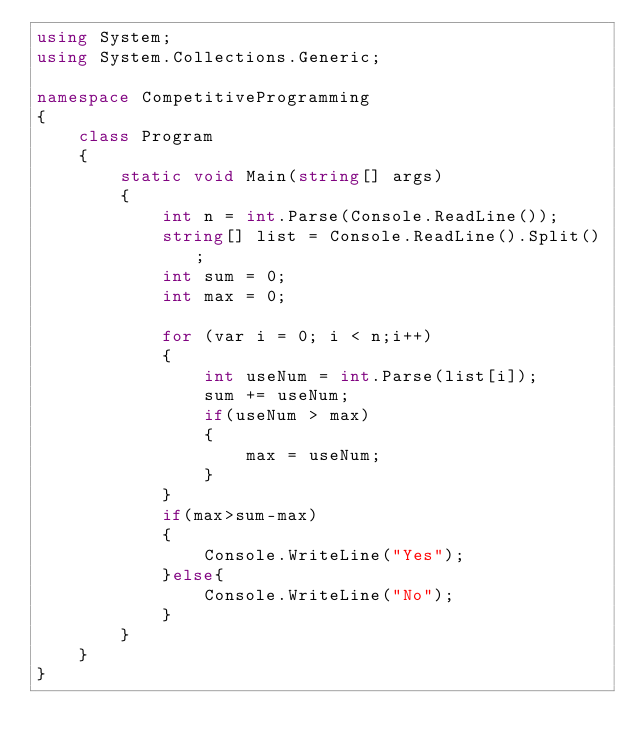Convert code to text. <code><loc_0><loc_0><loc_500><loc_500><_C#_>using System;
using System.Collections.Generic;

namespace CompetitiveProgramming
{
    class Program
    {
        static void Main(string[] args)
        {
            int n = int.Parse(Console.ReadLine());
            string[] list = Console.ReadLine().Split();
            int sum = 0;
            int max = 0;

            for (var i = 0; i < n;i++)
            {
                int useNum = int.Parse(list[i]);
                sum += useNum;
                if(useNum > max)
                {
                    max = useNum;
                }
            }
            if(max>sum-max)
            {
                Console.WriteLine("Yes");
            }else{
                Console.WriteLine("No");
            }
        }
    }
}
</code> 